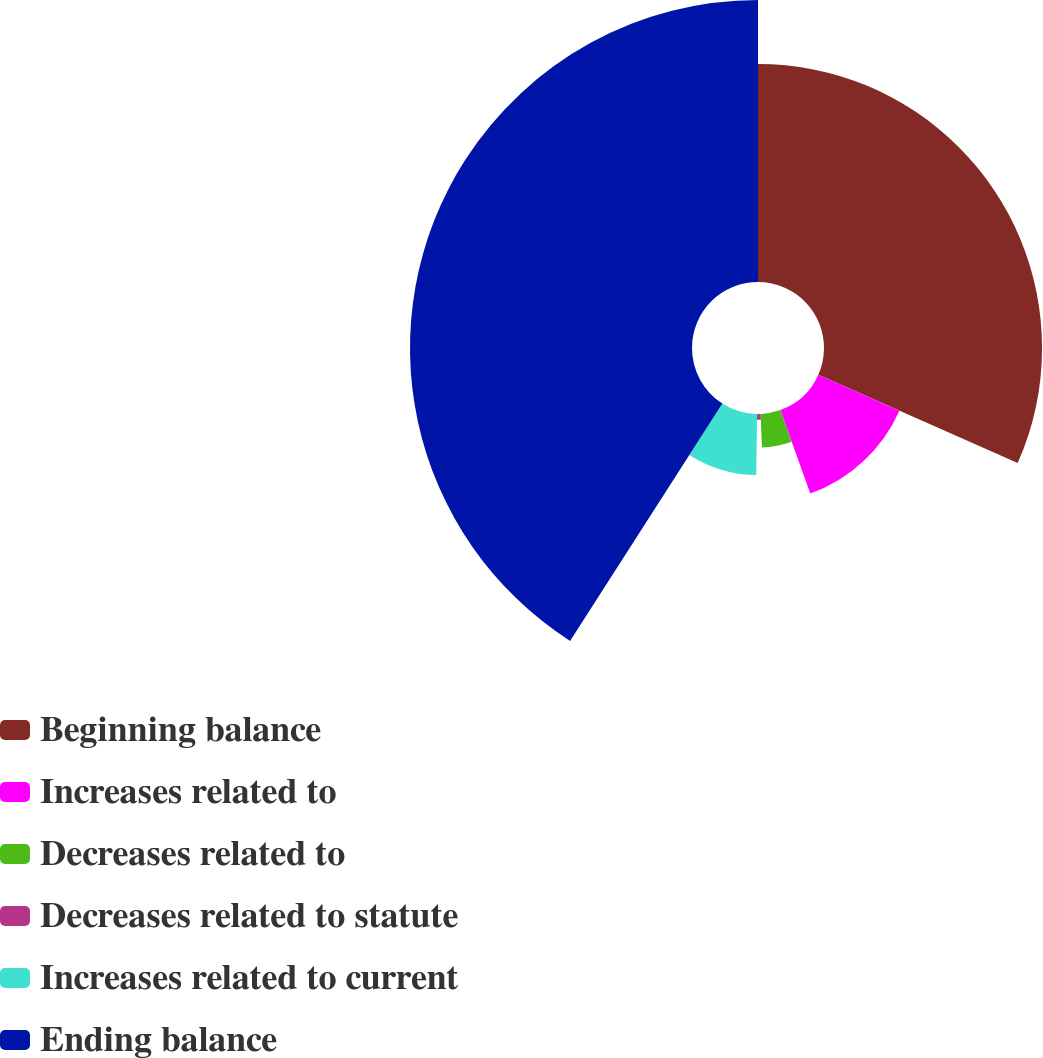Convert chart. <chart><loc_0><loc_0><loc_500><loc_500><pie_chart><fcel>Beginning balance<fcel>Increases related to<fcel>Decreases related to<fcel>Decreases related to statute<fcel>Increases related to current<fcel>Ending balance<nl><fcel>31.64%<fcel>12.87%<fcel>4.86%<fcel>0.85%<fcel>8.86%<fcel>40.92%<nl></chart> 